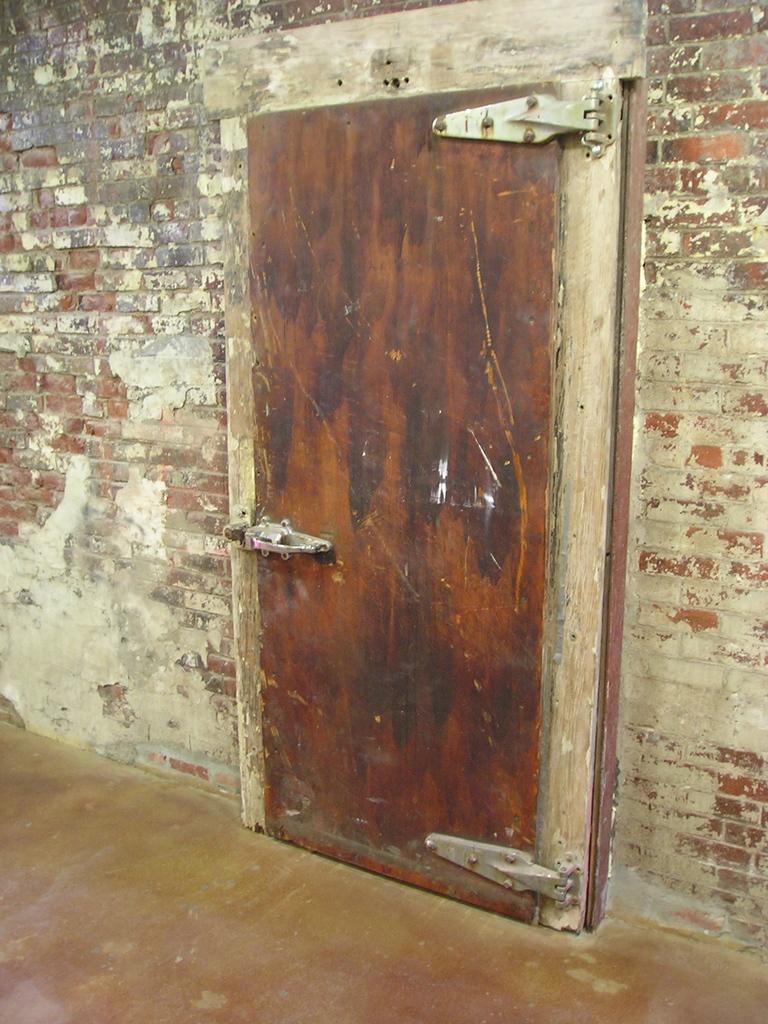In one or two sentences, can you explain what this image depicts? In this picture we can see a brick wall, there is a door here. 